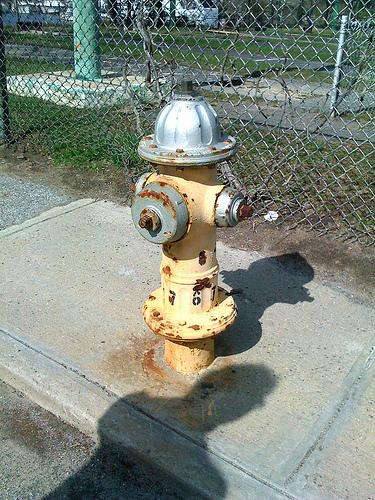Give an overall impression of the image, including its main object and general surroundings. A rusty fire hydrant stands on a concrete sidewalk beside a chain link fence, with shadows of a hydrant and a person on the ground. Point out the two types of shadows noticeable in this snapshot and where they fall. Shadows of a person and a fire hydrant cast on the sidewalk can be observed. What two colors dominate the fire hydrant, and what condition is it in? The fire hydrant is rusted, with silver and yellow as its primary colors. Describe the fencing and any particular objects or features found in close proximity. A metal chain link fence is present, with green grass, vines, branches, and metal posts nearby. Mention the significant elements in this picture, including the main object and surrounding environment. A rusty yellow fire hydrant, the sidewalk with rust stains, the shadow of a person, and a chain link fence with green grass behind it. What kind of fence is visible in the image, and what can be seen through it? A metal chain link fence is seen, with green grass, vines, and branches on the other side. In a few words, describe the appearance of the sidewalk and the ground around it. The sidewalk is gray concrete with rust stains, gravel, and a rust ring on it. Describe the condition of the fire hydrant and any specific details about it. The fire hydrant is rusty with silver and yellow colors, and it has a rusty bolt on it. Provide a brief description of the most prominent object in the image. A rusty old fire hydrant with silver and yellow colors stands on the sidewalk. 